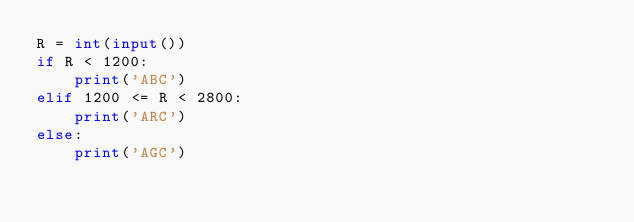<code> <loc_0><loc_0><loc_500><loc_500><_Python_>R = int(input())
if R < 1200:
    print('ABC')
elif 1200 <= R < 2800:
    print('ARC')
else:
    print('AGC')</code> 